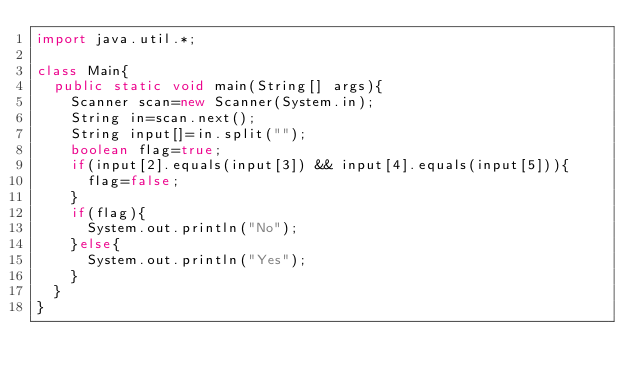Convert code to text. <code><loc_0><loc_0><loc_500><loc_500><_Java_>import java.util.*;
 
class Main{
  public static void main(String[] args){
    Scanner scan=new Scanner(System.in);
    String in=scan.next();
    String input[]=in.split("");
    boolean flag=true;
    if(input[2].equals(input[3]) && input[4].equals(input[5])){
      flag=false;
    }
    if(flag){
      System.out.println("No");
    }else{
      System.out.println("Yes");
    }
  }
}</code> 